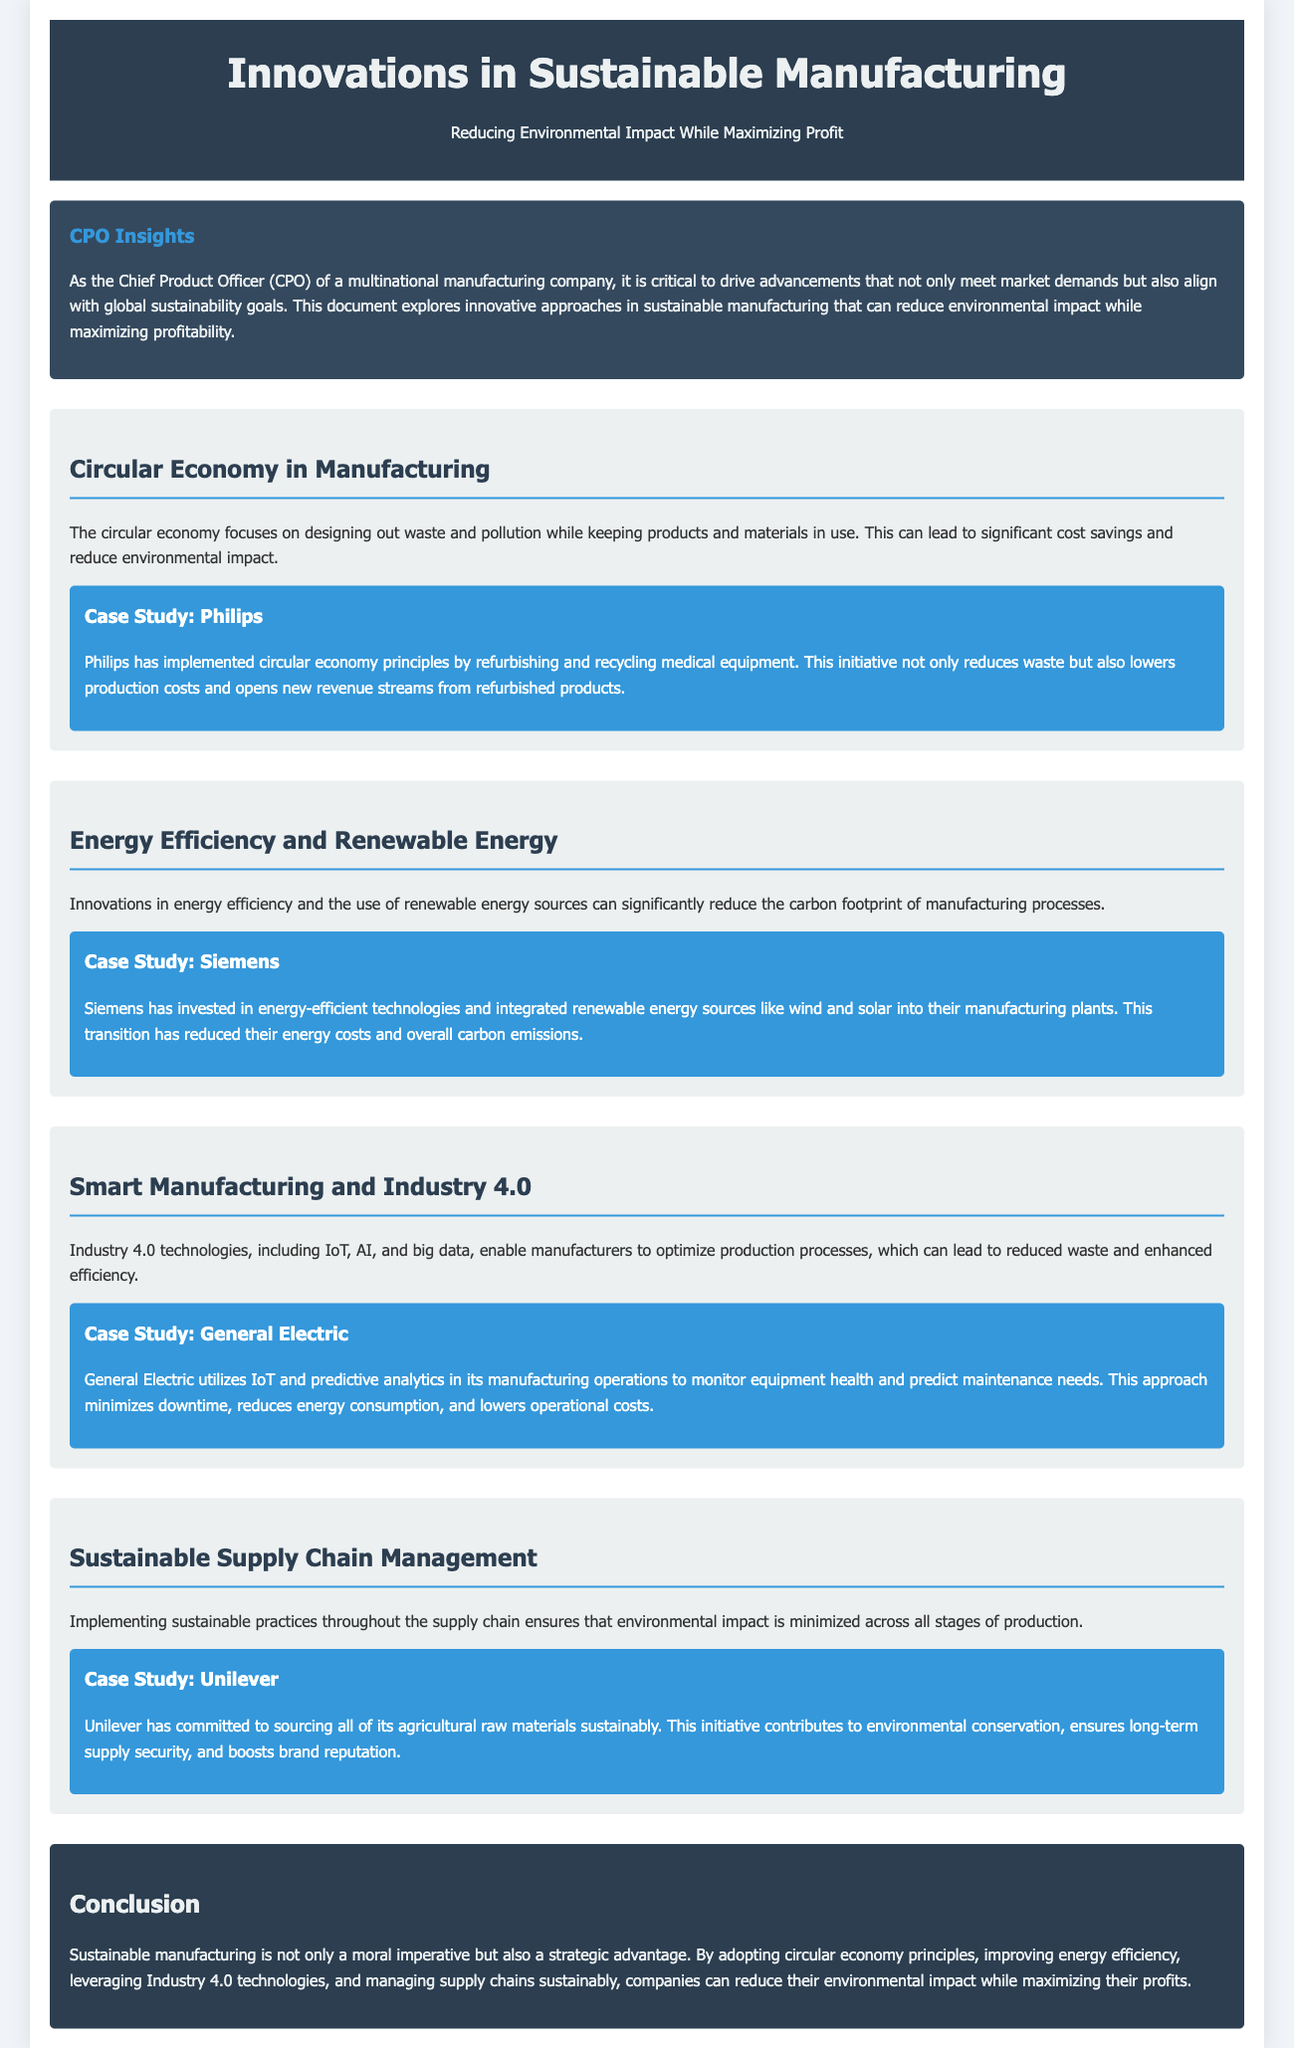What is the main focus of the whitepaper? The whitepaper focuses on innovations in sustainable manufacturing that reduce environmental impact while maximizing profit.
Answer: Innovations in sustainable manufacturing What company is mentioned in the case study related to circular economy? The case study highlights Philips as a company implementing circular economy principles.
Answer: Philips What two renewable energy sources are integrated by Siemens? Siemens has integrated wind and solar energy sources into their manufacturing plants.
Answer: Wind and solar Which technology does General Electric use to monitor equipment health? General Electric utilizes IoT and predictive analytics for monitoring equipment health.
Answer: IoT What type of manufacturing does Industry 4.0 represent? Industry 4.0 refers to the integration of advanced technologies in manufacturing processes.
Answer: Advanced technologies What commitment has Unilever made regarding its raw materials? Unilever is committed to sourcing all its agricultural raw materials sustainably.
Answer: Sustainably What is the strategic advantage of sustainable manufacturing? Sustainable manufacturing offers companies a moral imperative and a strategic advantage.
Answer: Strategic advantage What principle is emphasized to reduce waste in manufacturing? The whitepaper emphasizes circular economy principles to reduce waste in manufacturing.
Answer: Circular economy principles 